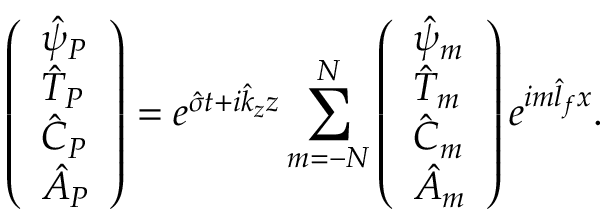Convert formula to latex. <formula><loc_0><loc_0><loc_500><loc_500>\left ( \begin{array} { l } { \hat { \psi } _ { P } } \\ { \hat { T } _ { P } } \\ { \hat { C } _ { P } } \\ { \hat { A } _ { P } } \end{array} \right ) = e ^ { \hat { \sigma } t + i \hat { k } _ { z } z } \sum _ { m = - N } ^ { N } \left ( \begin{array} { l } { \hat { \psi } _ { m } } \\ { \hat { T } _ { m } } \\ { \hat { C } _ { m } } \\ { \hat { A } _ { m } } \end{array} \right ) e ^ { i m \hat { l } _ { f } x } .</formula> 